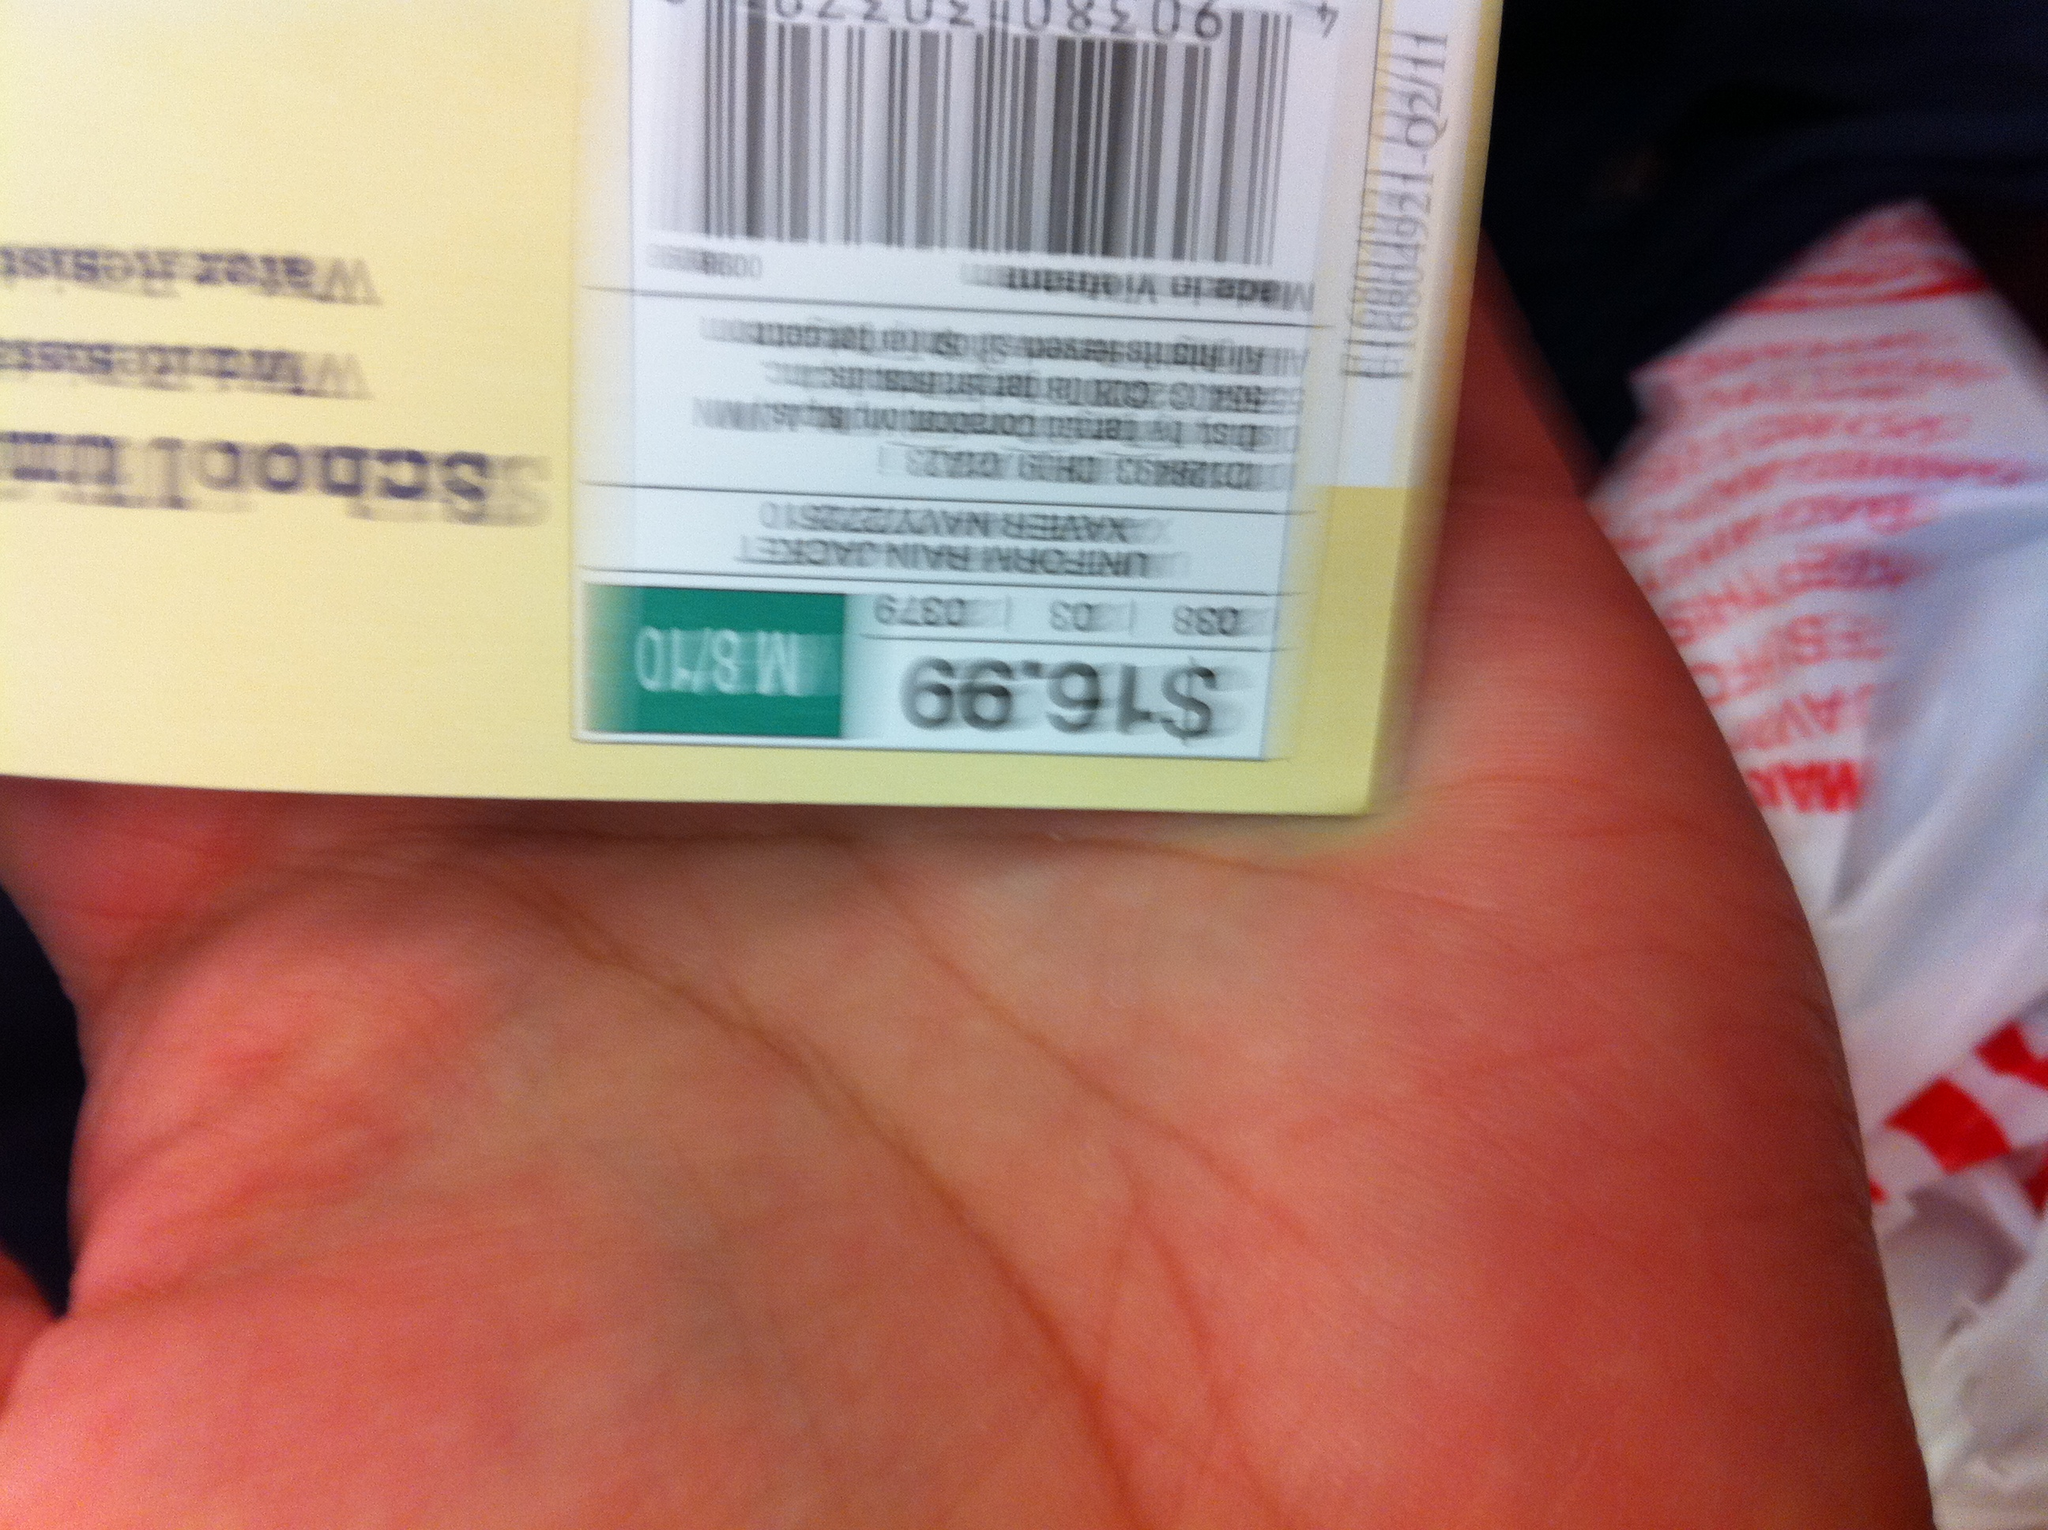What kind of store might this item be sold in? Given the clear and professional design of the tag with a distinct price point, it might be from a specialty or department store that sells new clothing or consumer goods. The exact nature of the store would require further context that isn't provided in the image. 